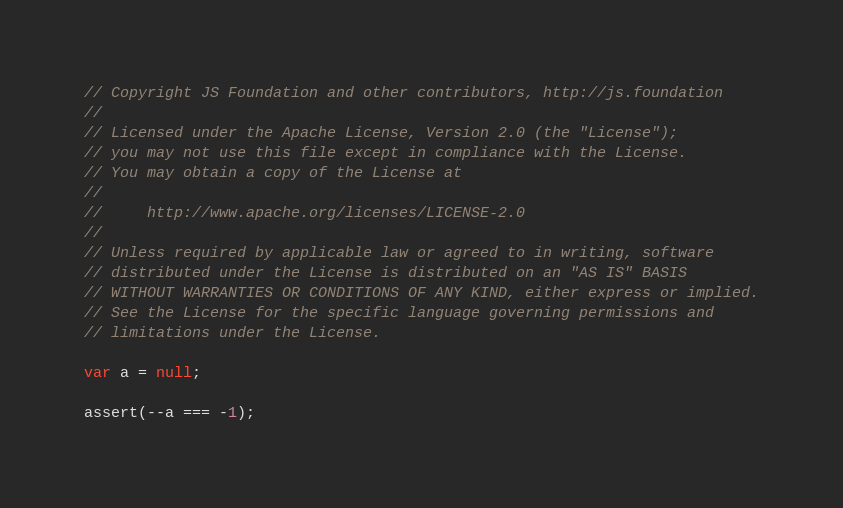Convert code to text. <code><loc_0><loc_0><loc_500><loc_500><_JavaScript_>// Copyright JS Foundation and other contributors, http://js.foundation
//
// Licensed under the Apache License, Version 2.0 (the "License");
// you may not use this file except in compliance with the License.
// You may obtain a copy of the License at
//
//     http://www.apache.org/licenses/LICENSE-2.0
//
// Unless required by applicable law or agreed to in writing, software
// distributed under the License is distributed on an "AS IS" BASIS
// WITHOUT WARRANTIES OR CONDITIONS OF ANY KIND, either express or implied.
// See the License for the specific language governing permissions and
// limitations under the License.

var a = null;

assert(--a === -1);
</code> 